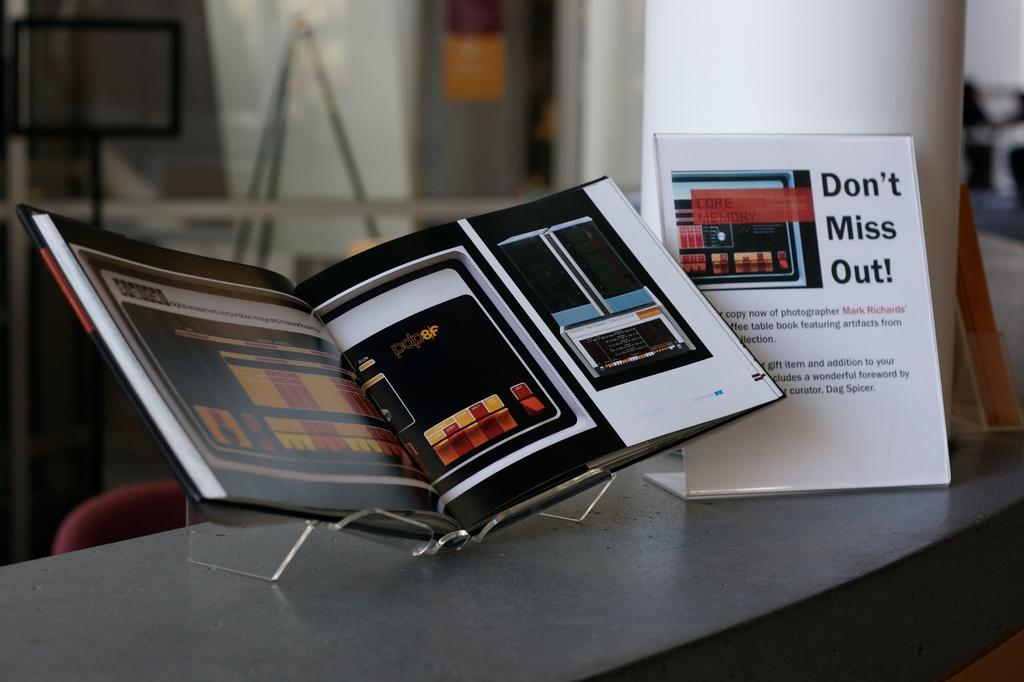Provide a one-sentence caption for the provided image. An open book sitting on a gray table with an advertisement stand next to the open box that says "Don't Miss out!". 